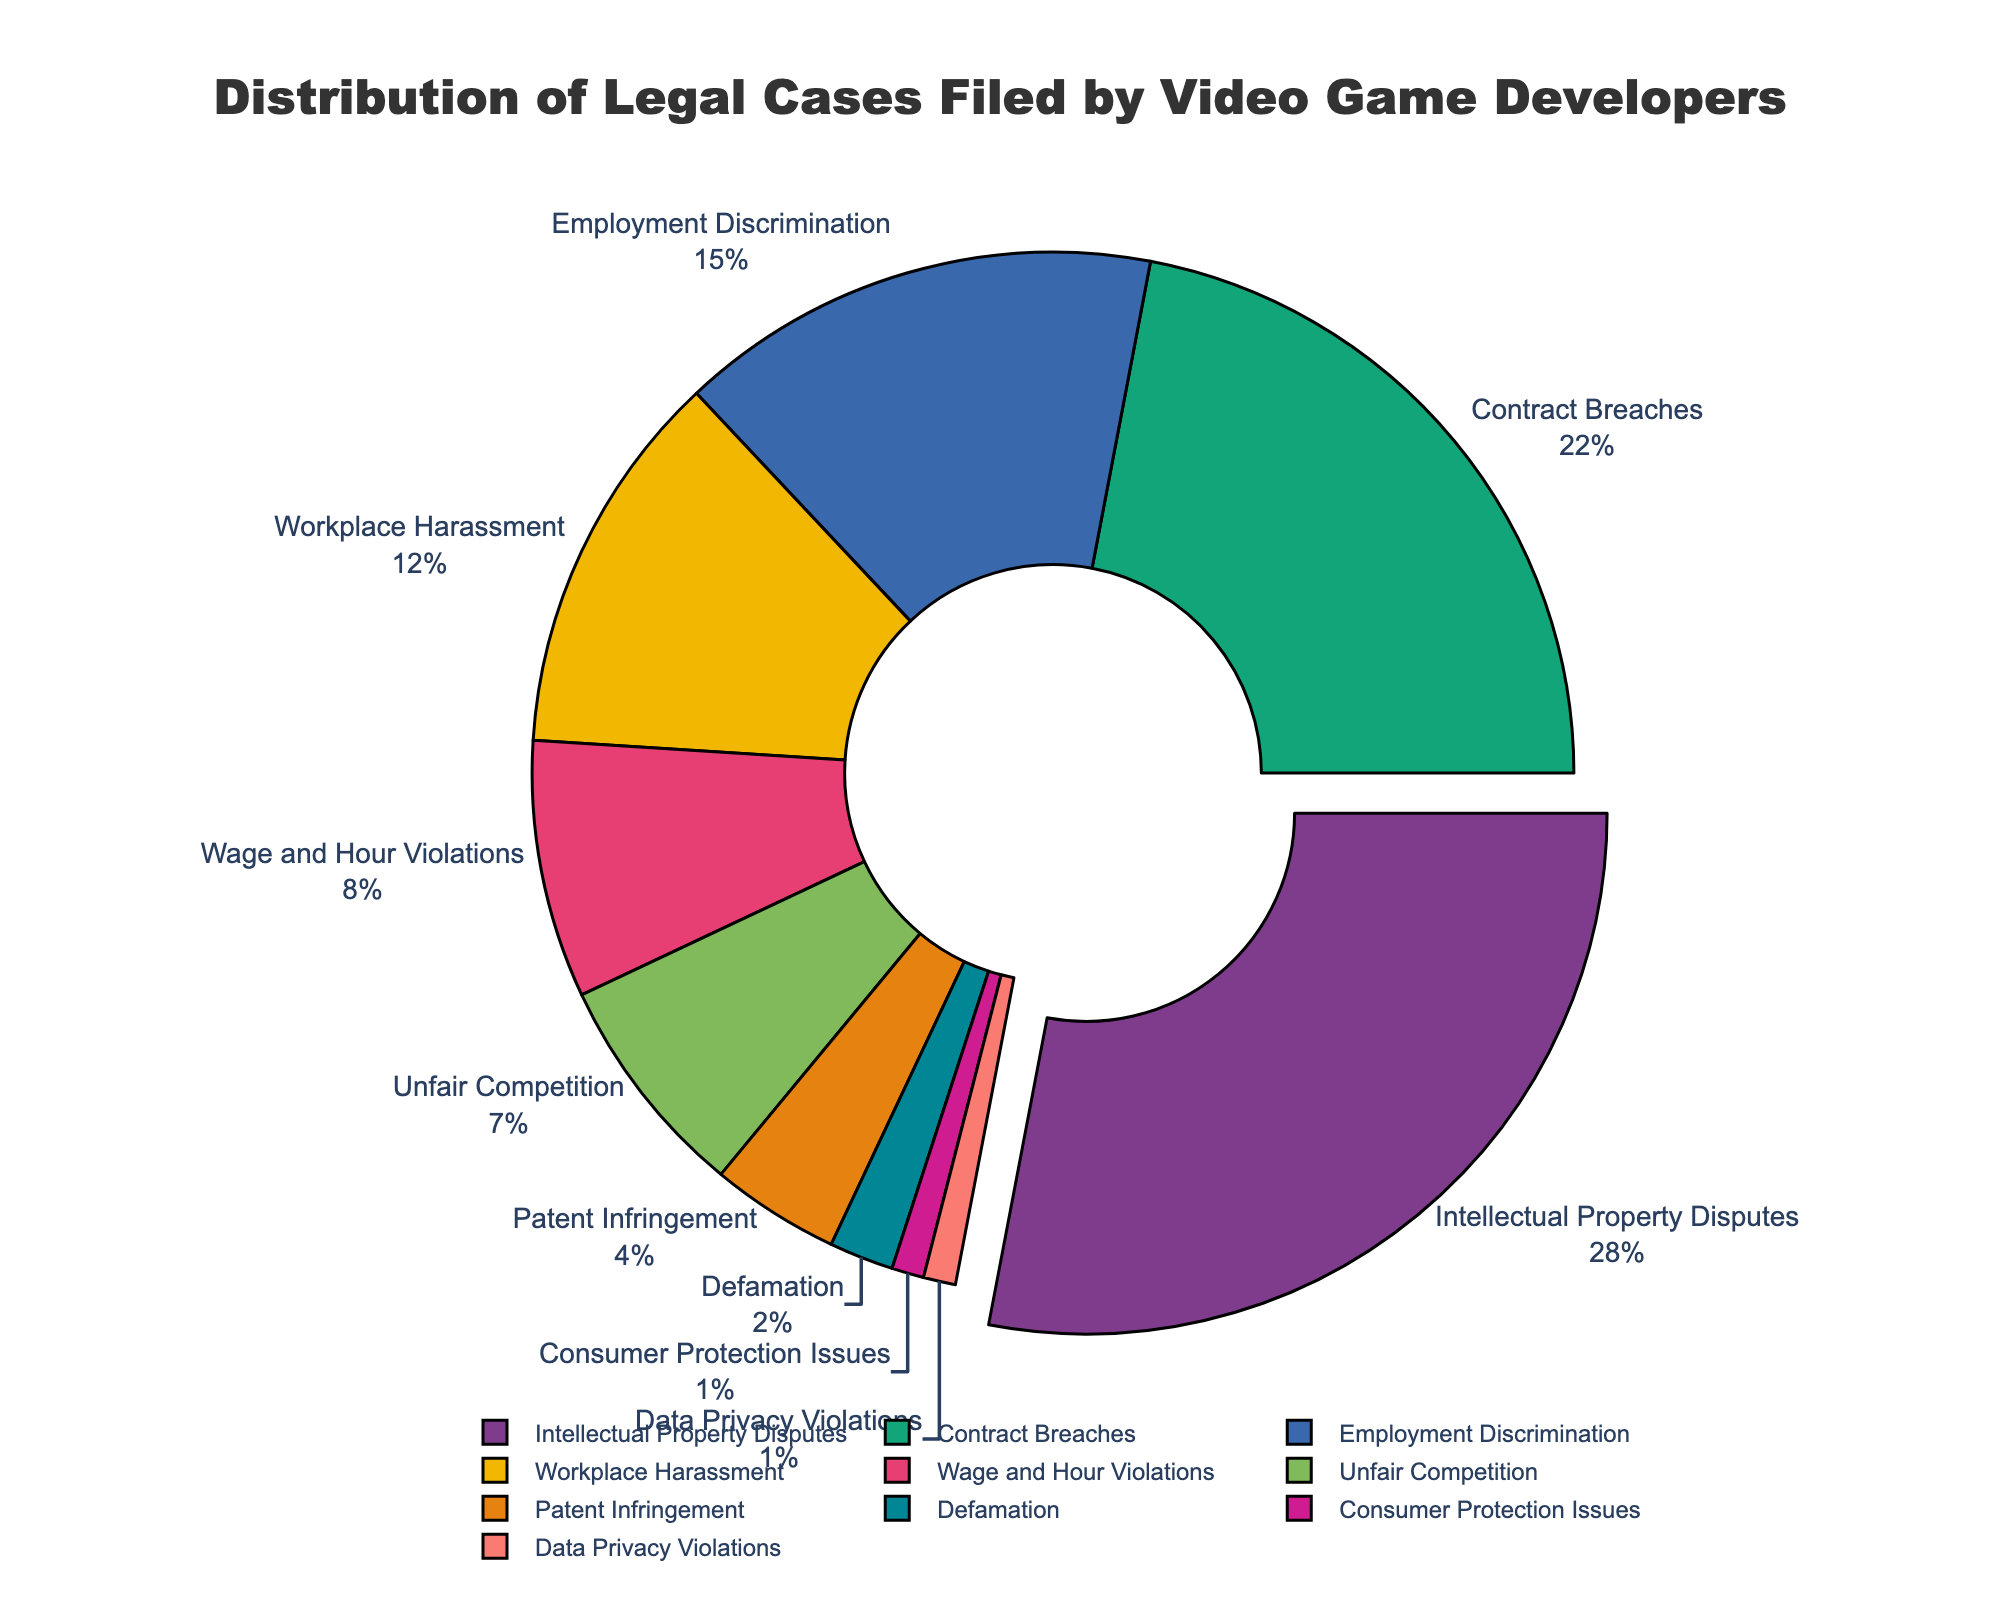Which category has the highest percentage of legal cases filed by video game developers? The figure shows that "Intellectual Property Disputes" has the largest segment of the pie chart, which is also pulled out slightly from the rest, indicating it holds the highest percentage.
Answer: Intellectual Property Disputes What is the combined percentage for the two smallest categories? The two smallest categories displayed in the pie chart are "Consumer Protection Issues" and "Data Privacy Violations," each with a percentage of 1%. Their combined percentage is 1% + 1% = 2%.
Answer: 2% Which category has a higher percentage of legal cases: Workplace Harassment or Employment Discrimination? The figure shows that "Employment Discrimination" accounts for 15%, while "Workplace Harassment" accounts for 12%. Comparing these, Employment Discrimination has a higher percentage.
Answer: Employment Discrimination What is the total percentage of legal cases attributed to Workplace Harassment, Wage and Hour Violations, and Unfair Competition combined? From the pie chart, Workplace Harassment is 12%, Wage and Hour Violations are 8%, and Unfair Competition is 7%. Summing these values: 12% + 8% + 7% = 27%.
Answer: 27% How much larger is the percentage of Contract Breaches compared to Patent Infringement? The figure shows Contract Breaches at 22% and Patent Infringement at 4%. The difference between these percentages is 22% - 4% = 18%.
Answer: 18% What is the average percentage of the categories with less than 5% of legal cases? The categories with less than 5% are Patent Infringement (4%), Defamation (2%), Consumer Protection Issues (1%), and Data Privacy Violations (1%). Their average is (4% + 2% + 1% + 1%) / 4 = 2%.
Answer: 2% Compare the combined percentage of the top three categories to the remaining categories. Which is higher, and by how much? The top three categories are Intellectual Property Disputes (28%), Contract Breaches (22%), and Employment Discrimination (15%), totaling 28% + 22% + 15% = 65%. The remaining categories combine to 100% - 65% = 35%. The top three categories account for 65% - 35% = 30% more.
Answer: Top three by 30% What percentage of the legal cases are not related to Intellectual Property Disputes or Contract Breaches? The percentages for Intellectual Property Disputes and Contract Breaches are 28% and 22%, respectively. Their combined percentage is 28% + 22% = 50%. Therefore, the percentage not related to these categories is 100% - 50% = 50%.
Answer: 50% What is the ratio of cases related to Workplace Harassment to those related to Defamation? The chart shows Workplace Harassment at 12% and Defamation at 2%. The ratio of Workplace Harassment to Defamation is 12% / 2% = 6 to 1.
Answer: 6 to 1 